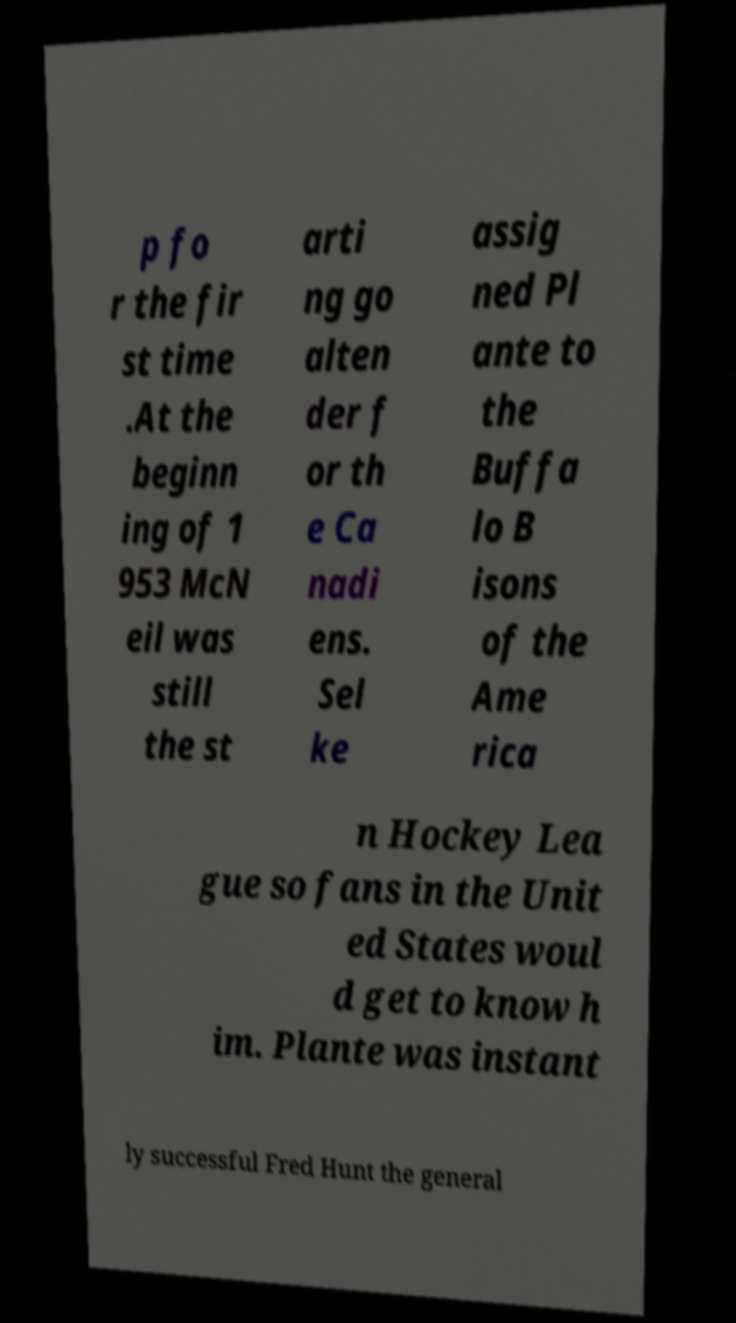Could you assist in decoding the text presented in this image and type it out clearly? p fo r the fir st time .At the beginn ing of 1 953 McN eil was still the st arti ng go alten der f or th e Ca nadi ens. Sel ke assig ned Pl ante to the Buffa lo B isons of the Ame rica n Hockey Lea gue so fans in the Unit ed States woul d get to know h im. Plante was instant ly successful Fred Hunt the general 